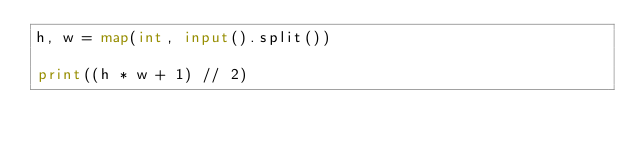Convert code to text. <code><loc_0><loc_0><loc_500><loc_500><_Python_>h, w = map(int, input().split())

print((h * w + 1) // 2)
</code> 